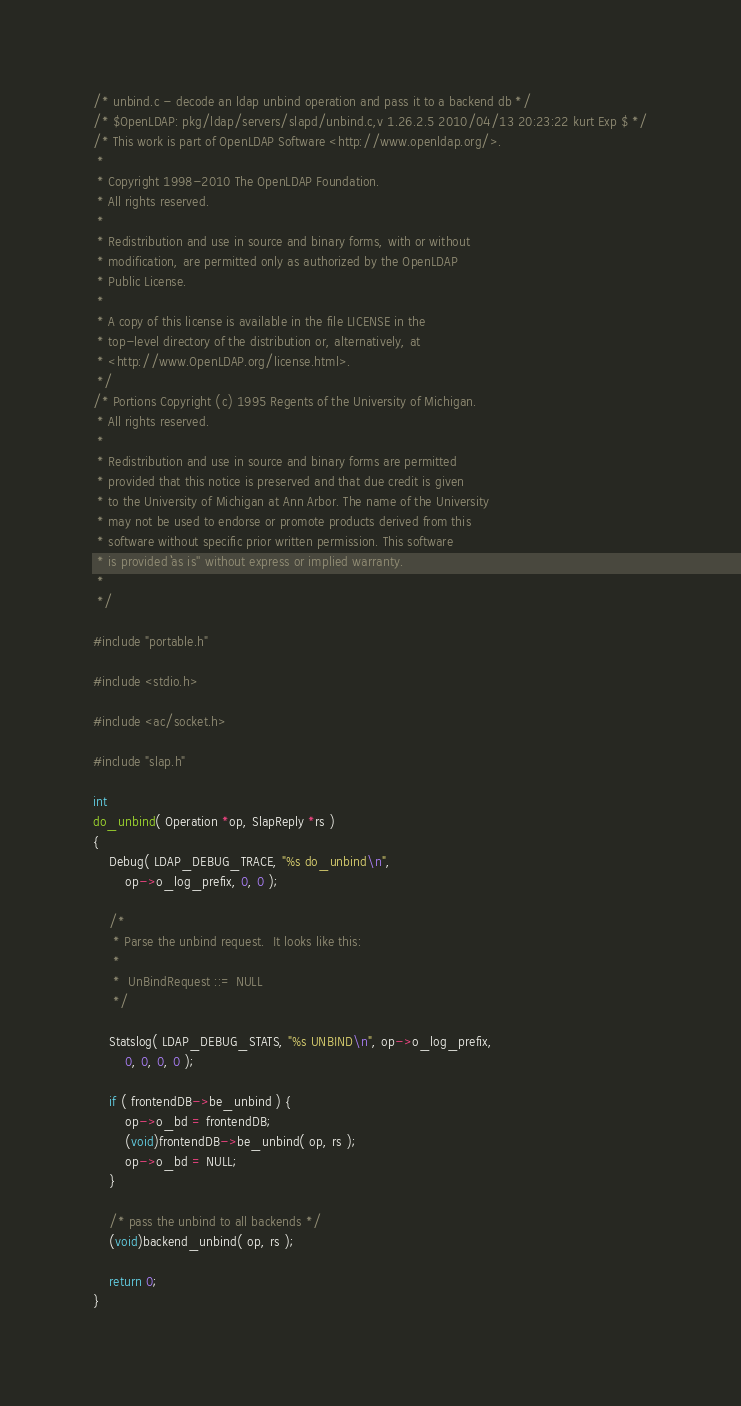Convert code to text. <code><loc_0><loc_0><loc_500><loc_500><_C_>/* unbind.c - decode an ldap unbind operation and pass it to a backend db */
/* $OpenLDAP: pkg/ldap/servers/slapd/unbind.c,v 1.26.2.5 2010/04/13 20:23:22 kurt Exp $ */
/* This work is part of OpenLDAP Software <http://www.openldap.org/>.
 *
 * Copyright 1998-2010 The OpenLDAP Foundation.
 * All rights reserved.
 *
 * Redistribution and use in source and binary forms, with or without
 * modification, are permitted only as authorized by the OpenLDAP
 * Public License.
 *
 * A copy of this license is available in the file LICENSE in the
 * top-level directory of the distribution or, alternatively, at
 * <http://www.OpenLDAP.org/license.html>.
 */
/* Portions Copyright (c) 1995 Regents of the University of Michigan.
 * All rights reserved.
 *
 * Redistribution and use in source and binary forms are permitted
 * provided that this notice is preserved and that due credit is given
 * to the University of Michigan at Ann Arbor. The name of the University
 * may not be used to endorse or promote products derived from this
 * software without specific prior written permission. This software
 * is provided ``as is'' without express or implied warranty.
 *
 */

#include "portable.h"

#include <stdio.h>

#include <ac/socket.h>

#include "slap.h"

int
do_unbind( Operation *op, SlapReply *rs )
{
	Debug( LDAP_DEBUG_TRACE, "%s do_unbind\n",
		op->o_log_prefix, 0, 0 );

	/*
	 * Parse the unbind request.  It looks like this:
	 *
	 *	UnBindRequest ::= NULL
	 */

	Statslog( LDAP_DEBUG_STATS, "%s UNBIND\n", op->o_log_prefix,
		0, 0, 0, 0 );

	if ( frontendDB->be_unbind ) {
		op->o_bd = frontendDB;
		(void)frontendDB->be_unbind( op, rs );
		op->o_bd = NULL;
	}

	/* pass the unbind to all backends */
	(void)backend_unbind( op, rs );

	return 0;
}

</code> 